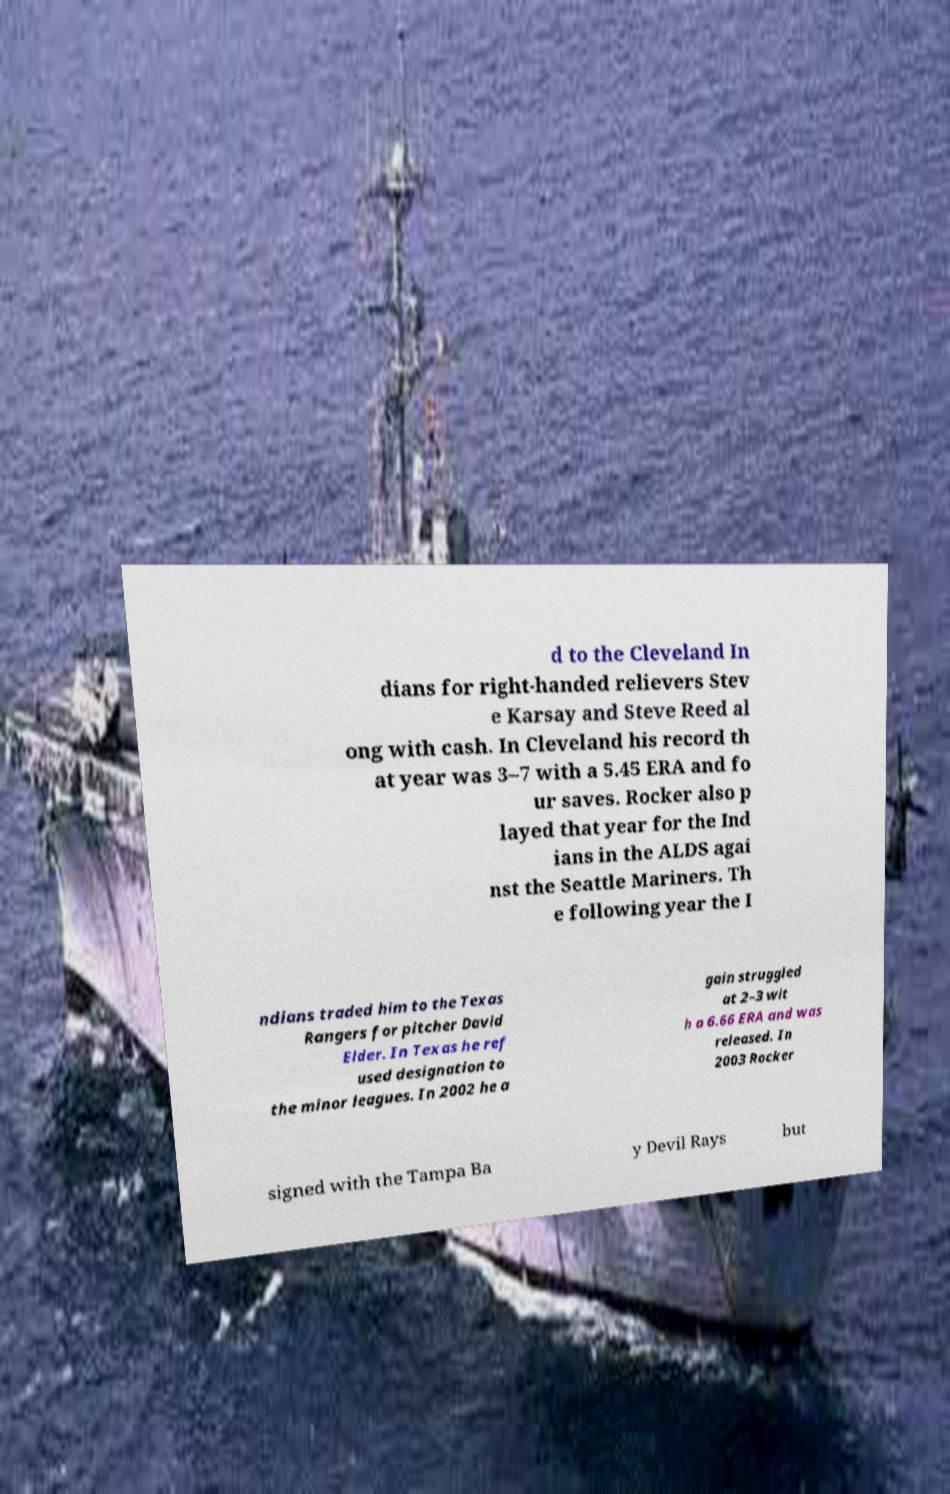Could you extract and type out the text from this image? d to the Cleveland In dians for right-handed relievers Stev e Karsay and Steve Reed al ong with cash. In Cleveland his record th at year was 3–7 with a 5.45 ERA and fo ur saves. Rocker also p layed that year for the Ind ians in the ALDS agai nst the Seattle Mariners. Th e following year the I ndians traded him to the Texas Rangers for pitcher David Elder. In Texas he ref used designation to the minor leagues. In 2002 he a gain struggled at 2–3 wit h a 6.66 ERA and was released. In 2003 Rocker signed with the Tampa Ba y Devil Rays but 